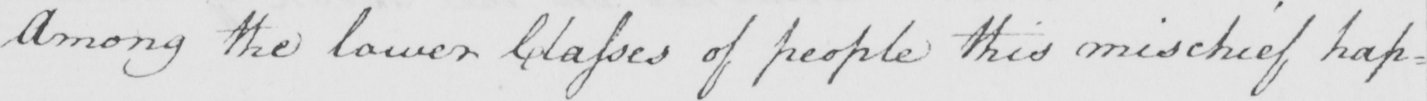Can you tell me what this handwritten text says? Among the lower classes of people this mischief hap= 